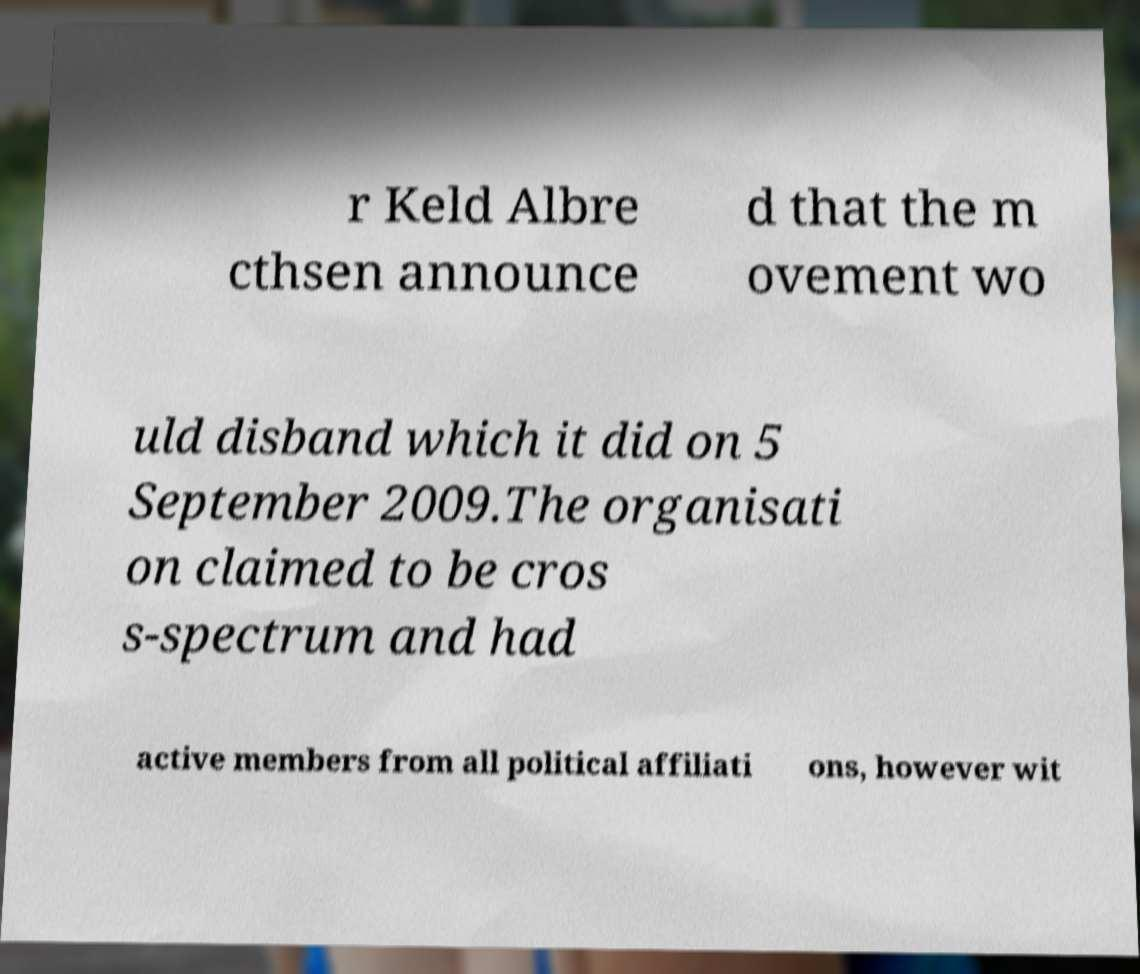I need the written content from this picture converted into text. Can you do that? r Keld Albre cthsen announce d that the m ovement wo uld disband which it did on 5 September 2009.The organisati on claimed to be cros s-spectrum and had active members from all political affiliati ons, however wit 